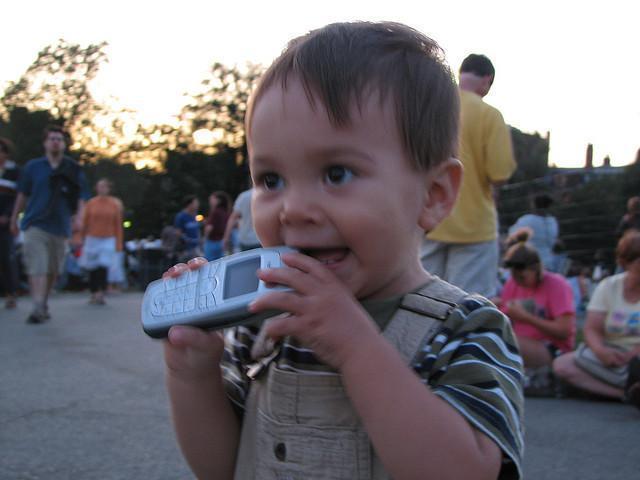How many cell phones are there?
Give a very brief answer. 1. How many people are there?
Give a very brief answer. 7. How many birds are on the building?
Give a very brief answer. 0. 